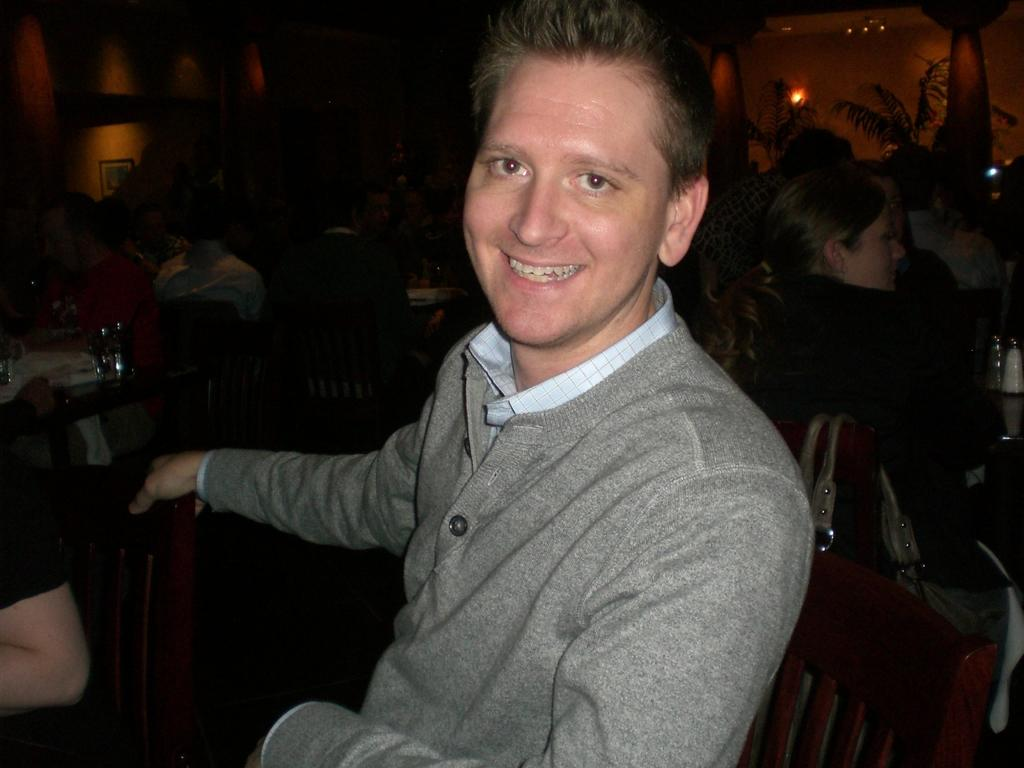What is the man in the image doing? The man is sitting on a chair in the image. What is the man's facial expression in the image? The man is smiling in the image. What is the man doing with his body in the image? The man is giving a pose for the picture. Can you describe the people visible in the background of the image? There are people visible in the background of the image, but their specific actions or appearances cannot be determined from the provided facts. How would you describe the lighting in the image? The background appears to be dark in the image. What type of pump is visible in the image? There is no pump present in the image. What government policies are being discussed in the image? There is no discussion of government policies or any indication of a political context in the image. 